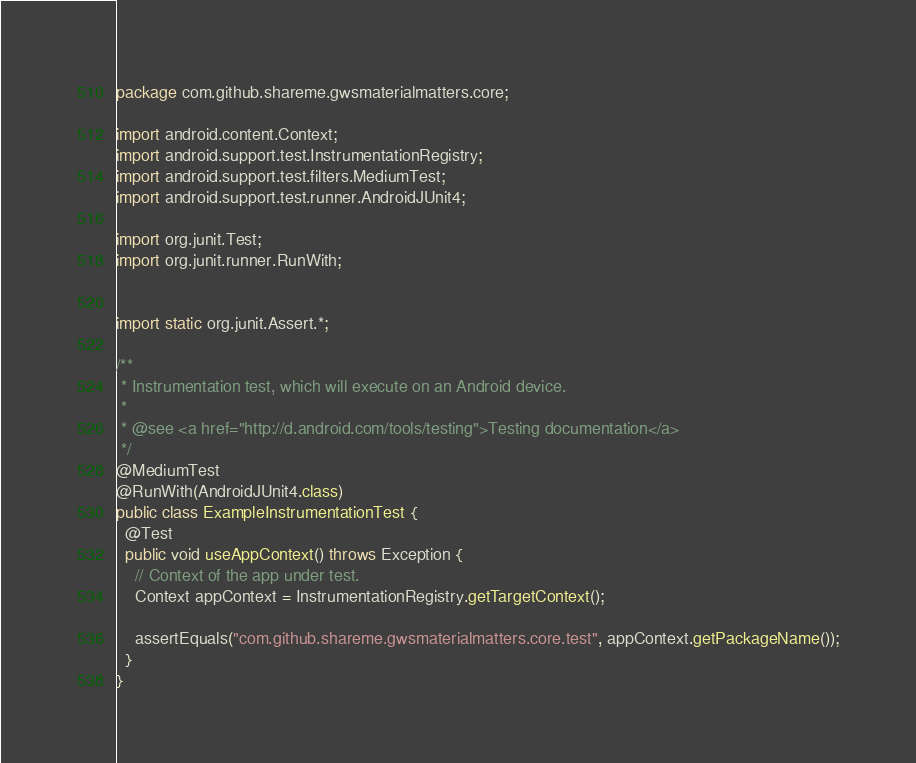<code> <loc_0><loc_0><loc_500><loc_500><_Java_>package com.github.shareme.gwsmaterialmatters.core;

import android.content.Context;
import android.support.test.InstrumentationRegistry;
import android.support.test.filters.MediumTest;
import android.support.test.runner.AndroidJUnit4;

import org.junit.Test;
import org.junit.runner.RunWith;


import static org.junit.Assert.*;

/**
 * Instrumentation test, which will execute on an Android device.
 *
 * @see <a href="http://d.android.com/tools/testing">Testing documentation</a>
 */
@MediumTest
@RunWith(AndroidJUnit4.class)
public class ExampleInstrumentationTest {
  @Test
  public void useAppContext() throws Exception {
    // Context of the app under test.
    Context appContext = InstrumentationRegistry.getTargetContext();

    assertEquals("com.github.shareme.gwsmaterialmatters.core.test", appContext.getPackageName());
  }
}</code> 